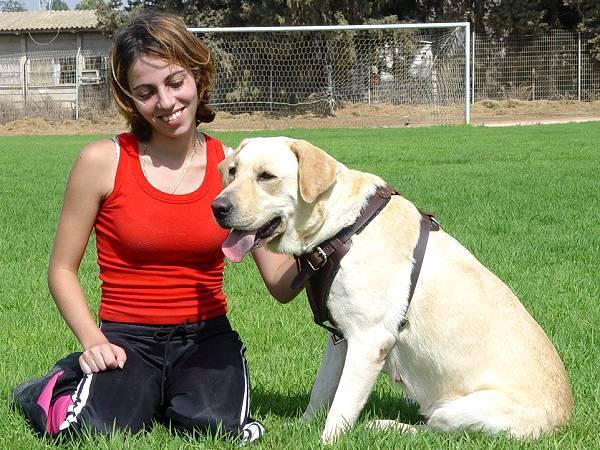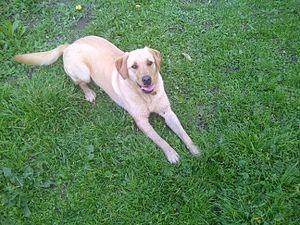The first image is the image on the left, the second image is the image on the right. Assess this claim about the two images: "A yellow dog is next to a woman.". Correct or not? Answer yes or no. Yes. The first image is the image on the left, the second image is the image on the right. Assess this claim about the two images: "There are no humans in the image on the right.". Correct or not? Answer yes or no. Yes. 